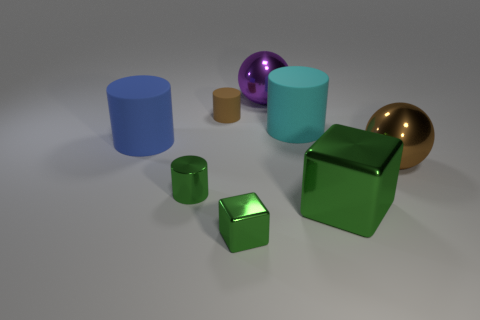Subtract all blue cylinders. How many cylinders are left? 3 Add 1 large green cubes. How many objects exist? 9 Subtract all gray cylinders. Subtract all blue balls. How many cylinders are left? 4 Subtract all balls. How many objects are left? 6 Add 8 large brown shiny objects. How many large brown shiny objects are left? 9 Add 7 big blue cylinders. How many big blue cylinders exist? 8 Subtract 1 purple balls. How many objects are left? 7 Subtract all large cyan things. Subtract all purple spheres. How many objects are left? 6 